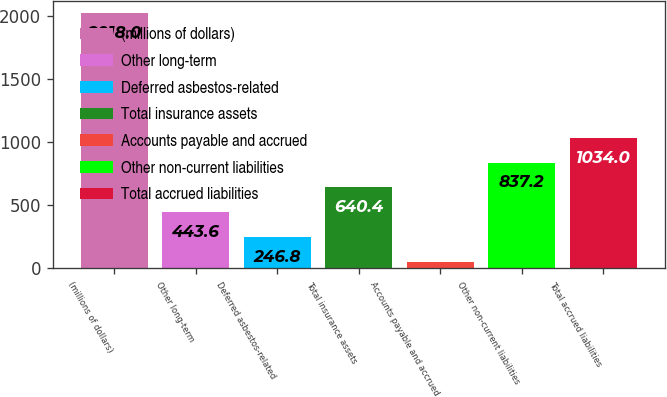Convert chart to OTSL. <chart><loc_0><loc_0><loc_500><loc_500><bar_chart><fcel>(millions of dollars)<fcel>Other long-term<fcel>Deferred asbestos-related<fcel>Total insurance assets<fcel>Accounts payable and accrued<fcel>Other non-current liabilities<fcel>Total accrued liabilities<nl><fcel>2018<fcel>443.6<fcel>246.8<fcel>640.4<fcel>50<fcel>837.2<fcel>1034<nl></chart> 